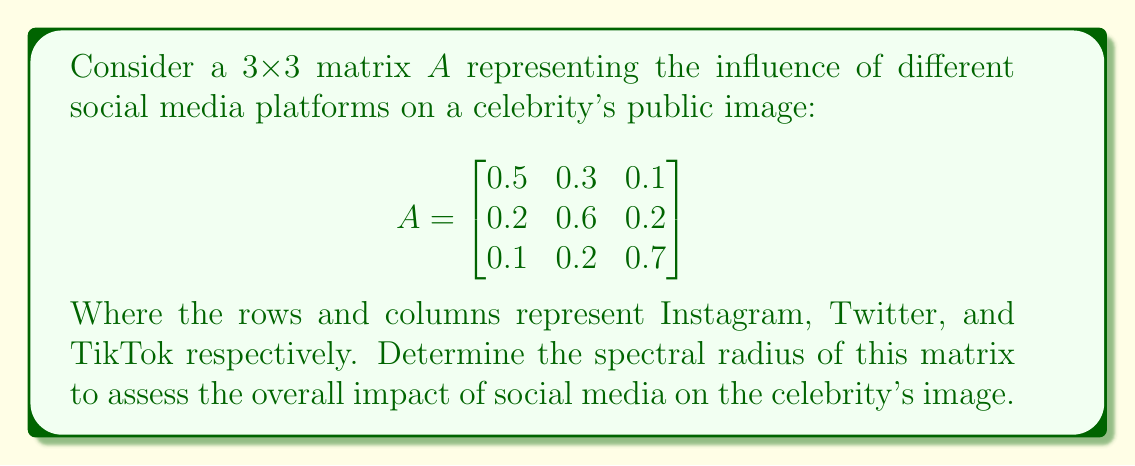Could you help me with this problem? To find the spectral radius of matrix $A$, we need to follow these steps:

1) First, calculate the characteristic polynomial of $A$:
   $det(A - \lambda I) = 0$

   $$\begin{vmatrix}
   0.5-\lambda & 0.3 & 0.1 \\
   0.2 & 0.6-\lambda & 0.2 \\
   0.1 & 0.2 & 0.7-\lambda
   \end{vmatrix} = 0$$

2) Expand the determinant:
   $(0.5-\lambda)((0.6-\lambda)(0.7-\lambda)-0.04) - 0.3(0.2(0.7-\lambda)-0.02) + 0.1(0.2(0.6-\lambda)-0.04) = 0$

3) Simplify:
   $-\lambda^3 + 1.8\lambda^2 - 0.98\lambda + 0.162 = 0$

4) Find the roots of this polynomial. These are the eigenvalues of $A$. Using a numerical method or a computer algebra system, we get:
   $\lambda_1 \approx 0.9053$
   $\lambda_2 \approx 0.4973$
   $\lambda_3 \approx 0.3974$

5) The spectral radius $\rho(A)$ is the maximum absolute value of the eigenvalues:
   $\rho(A) = max(|\lambda_1|, |\lambda_2|, |\lambda_3|) = |\lambda_1| \approx 0.9053$
Answer: $\rho(A) \approx 0.9053$ 